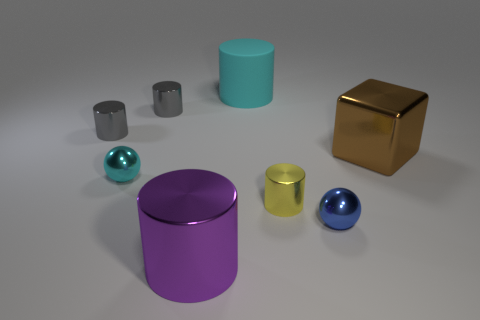How many gray cylinders must be subtracted to get 1 gray cylinders? 1 Subtract all cyan cylinders. How many cylinders are left? 4 Subtract all purple shiny cylinders. How many cylinders are left? 4 Add 2 cyan cylinders. How many objects exist? 10 Subtract all yellow blocks. Subtract all yellow cylinders. How many blocks are left? 1 Subtract all balls. How many objects are left? 6 Add 1 small blue things. How many small blue things exist? 2 Subtract 0 purple balls. How many objects are left? 8 Subtract all yellow shiny objects. Subtract all purple objects. How many objects are left? 6 Add 5 big purple cylinders. How many big purple cylinders are left? 6 